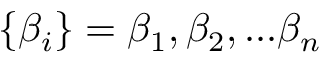<formula> <loc_0><loc_0><loc_500><loc_500>\{ \beta _ { i } \} = \beta _ { 1 } , \beta _ { 2 } , \dots \beta _ { n }</formula> 